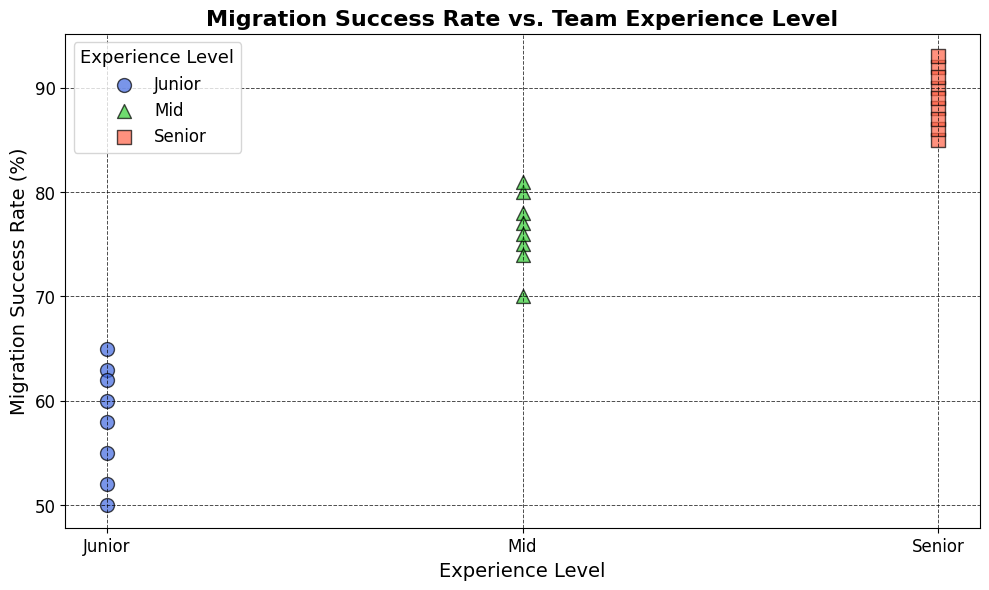Which Experience Level has the highest average success rate? To find the highest average success rate, calculate the average for each Experience Level: Junior (60+55+65+50+58+52+63+62) / 8 = 58.13, Mid (70+75+80+78+77+81+74+76) / 8 = 76.38, Senior (90+85+92+88+91+89+86+87+93) / 9 = 88.78. Senior has the highest average.
Answer: Senior Which Experience Level has the most data points? Count the number of data points for each Experience Level: Junior (8), Mid (8), Senior (9). Senior has the most data points.
Answer: Senior What is the highest success rate for the Junior Experience Level? Look at the data points for Junior and identify the highest value: 60, 55, 65, 50, 58, 52, 63, 62. The highest is 65.
Answer: 65 Which Experience Level shows the most variation in success rates? To determine variation visually, look at the spread or scatter of data points for each Experience Level. Junior shows more scattered points compared to Mid and Senior, indicating more variation.
Answer: Junior What is the difference in the average success rates between Mid and Senior Experience Levels? Calculate the average for Mid: (70+75+80+78+77+81+74+76) / 8 = 76.38. Calculate the average for Senior: (90+85+92+88+91+89+86+87+93) / 9 = 88.78. The difference is 88.78 - 76.38 = 12.4.
Answer: 12.4 Is there any overlap in success rates between Junior and Mid Experience Levels? Check if any success rates in the Junior range fall within the Mid range: Junior (50-65), Mid (70-81). There is no overlap in the values.
Answer: No How does the highest success rate for Senior compare to the lowest success rate for Junior? The highest success rate for Senior is 93, and the lowest for Junior is 50. Compare the two: 93 is higher than 50.
Answer: Higher Among the Experience Levels, which one generally has the lowest success rates? Visually examine the lowest points among the Experience Levels: Junior (50), Mid (70), Senior (85). Junior Experience Level generally has the lowest success rates.
Answer: Junior What is the median success rate for the Senior Experience Level? Sort the Senior data: 85, 86, 87, 88, 89, 90, 91, 92, 93. Median is the middle value in an ordered list of 9 values, which is 89.
Answer: 89 What's the range of success rates for the Mid Experience Level? Find the difference between the highest and lowest success rates for Mid: 81 (highest) - 70 (lowest) = 11.
Answer: 11 